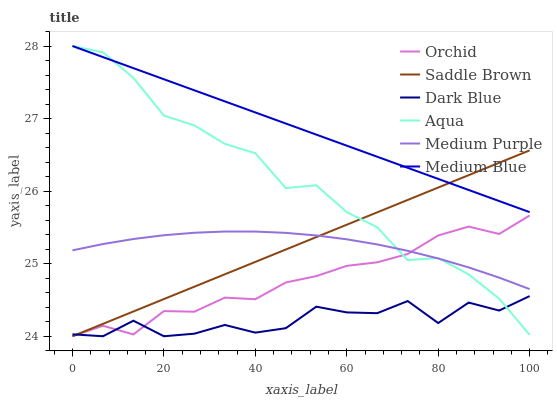Does Dark Blue have the minimum area under the curve?
Answer yes or no. Yes. Does Medium Blue have the maximum area under the curve?
Answer yes or no. Yes. Does Medium Purple have the minimum area under the curve?
Answer yes or no. No. Does Medium Purple have the maximum area under the curve?
Answer yes or no. No. Is Saddle Brown the smoothest?
Answer yes or no. Yes. Is Dark Blue the roughest?
Answer yes or no. Yes. Is Medium Blue the smoothest?
Answer yes or no. No. Is Medium Blue the roughest?
Answer yes or no. No. Does Medium Purple have the lowest value?
Answer yes or no. No. Does Medium Purple have the highest value?
Answer yes or no. No. Is Dark Blue less than Medium Purple?
Answer yes or no. Yes. Is Medium Blue greater than Dark Blue?
Answer yes or no. Yes. Does Dark Blue intersect Medium Purple?
Answer yes or no. No. 